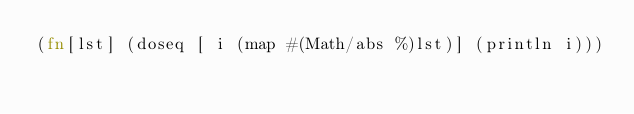Convert code to text. <code><loc_0><loc_0><loc_500><loc_500><_Clojure_>(fn[lst] (doseq [ i (map #(Math/abs %)lst)] (println i)))
</code> 